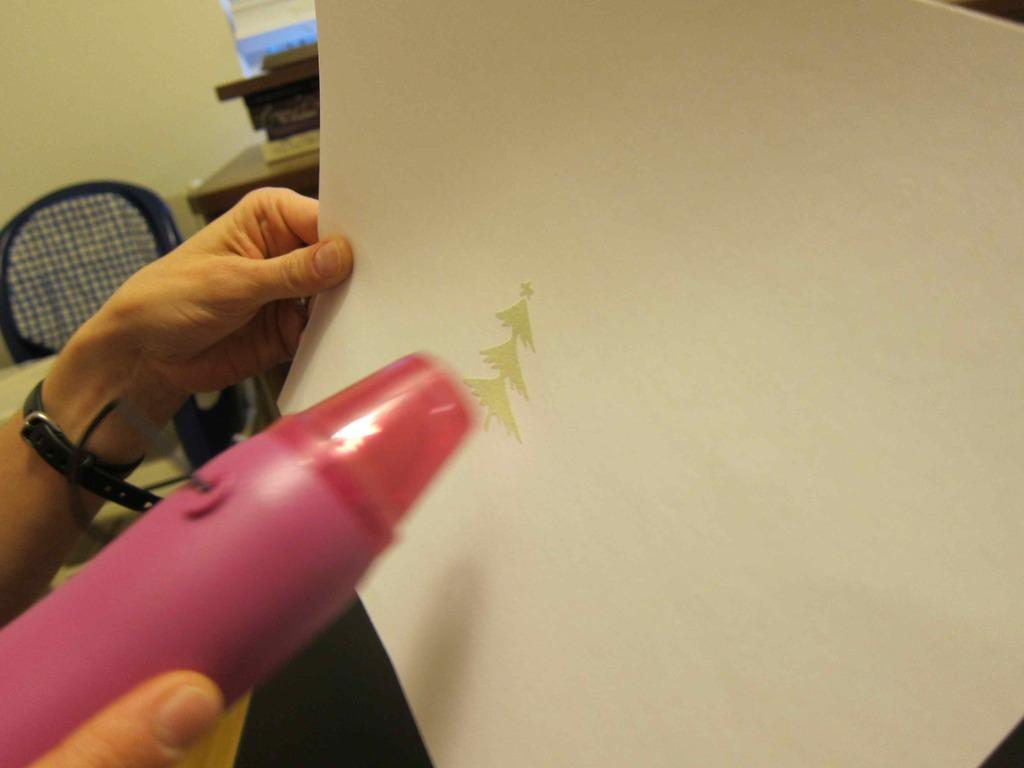What objects are being held by the hands in the image? The hands are holding a bottle and a pen in the image. What type of surface can be seen in the background of the image? There is a table in the background of the image. What type of furniture is present in the background of the image? There is a chair in the background of the image. What is the background of the image made of? There is a wall in the background of the image. What type of cracker is being used to care for the net in the image? There is no cracker, care, or net present in the image. 